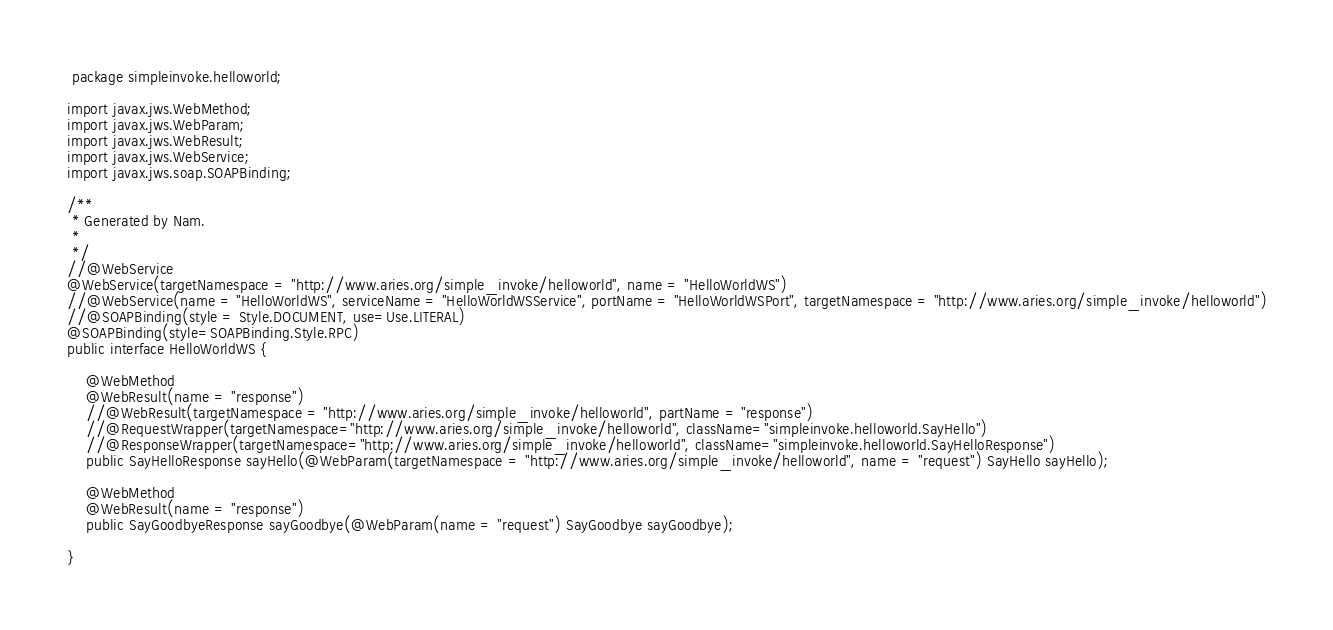<code> <loc_0><loc_0><loc_500><loc_500><_Java_> package simpleinvoke.helloworld;

import javax.jws.WebMethod;
import javax.jws.WebParam;
import javax.jws.WebResult;
import javax.jws.WebService;
import javax.jws.soap.SOAPBinding;

/**
 * Generated by Nam.
 *
 */
//@WebService
@WebService(targetNamespace = "http://www.aries.org/simple_invoke/helloworld", name = "HelloWorldWS")
//@WebService(name = "HelloWorldWS", serviceName = "HelloWorldWSService", portName = "HelloWorldWSPort", targetNamespace = "http://www.aries.org/simple_invoke/helloworld")
//@SOAPBinding(style = Style.DOCUMENT, use=Use.LITERAL)
@SOAPBinding(style=SOAPBinding.Style.RPC)
public interface HelloWorldWS {

	@WebMethod
	@WebResult(name = "response")
	//@WebResult(targetNamespace = "http://www.aries.org/simple_invoke/helloworld", partName = "response")
	//@RequestWrapper(targetNamespace="http://www.aries.org/simple_invoke/helloworld", className="simpleinvoke.helloworld.SayHello")
	//@ResponseWrapper(targetNamespace="http://www.aries.org/simple_invoke/helloworld", className="simpleinvoke.helloworld.SayHelloResponse")
	public SayHelloResponse sayHello(@WebParam(targetNamespace = "http://www.aries.org/simple_invoke/helloworld", name = "request") SayHello sayHello);

	@WebMethod
	@WebResult(name = "response")
	public SayGoodbyeResponse sayGoodbye(@WebParam(name = "request") SayGoodbye sayGoodbye);

}
</code> 